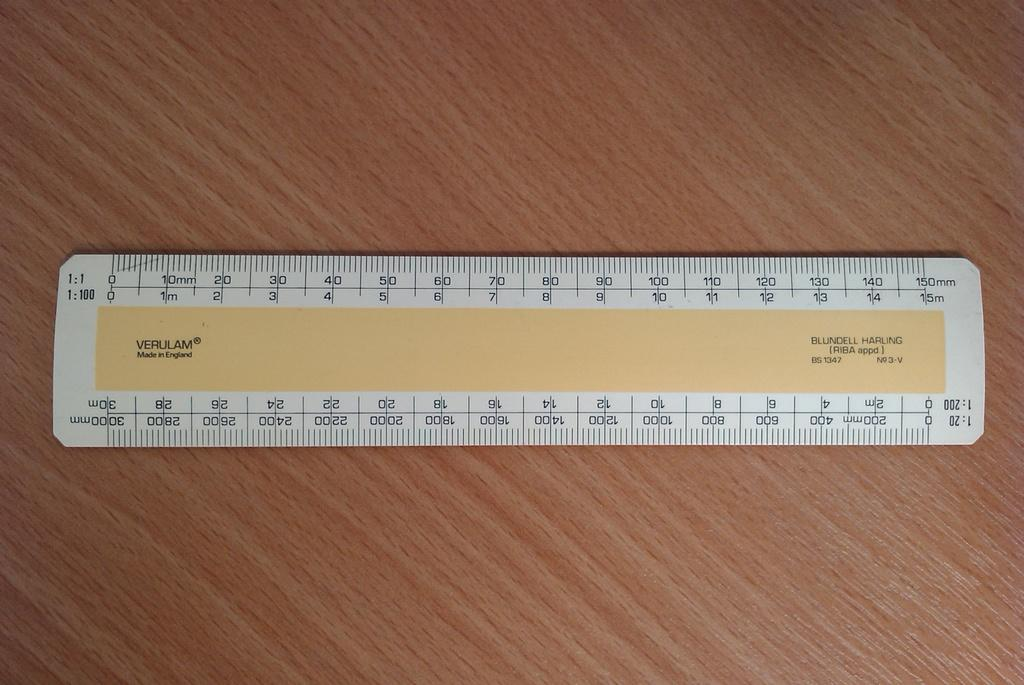<image>
Give a short and clear explanation of the subsequent image. A yellow and white Verulam ruler made in England. 